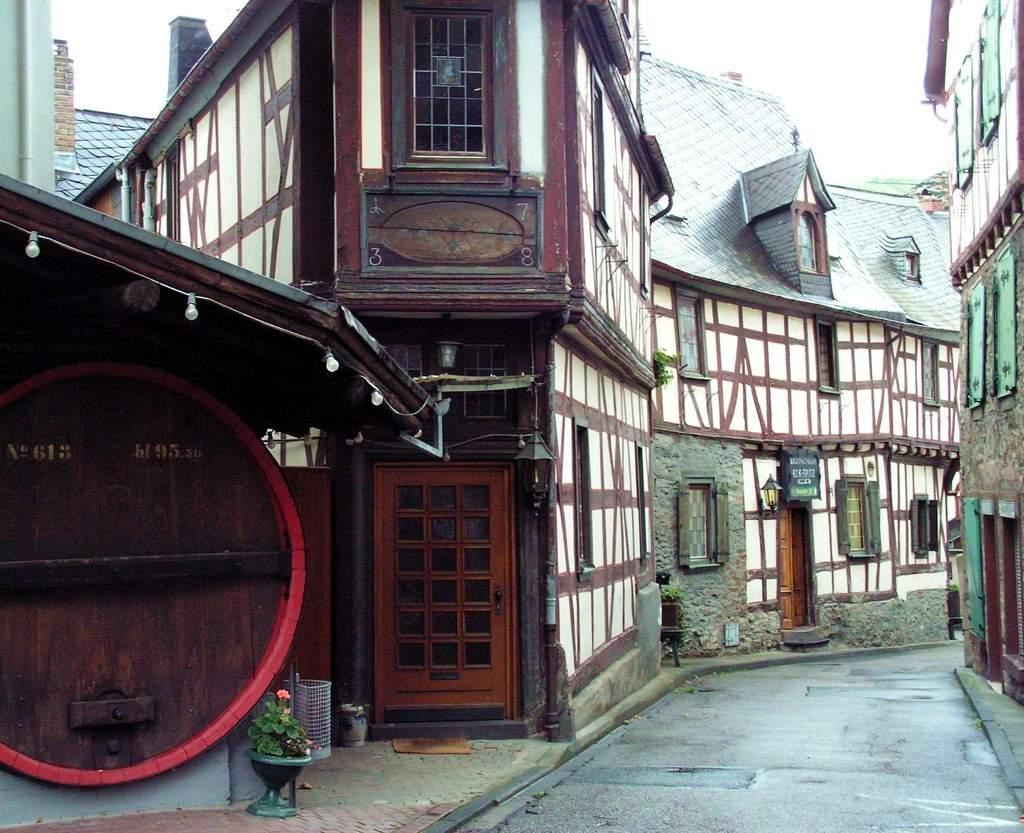What structures are located in the middle of the image? There are buildings in the middle of the image. What else can be seen in the middle of the image besides the buildings? There are lights visible in the middle of the image. What is visible at the top of the image? The sky is visible at the top of the image. What type of vegetation is at the bottom of the image? There is a plant at the bottom of the image. What type of skirt is hanging from the building in the image? There is no skirt present in the image; it features buildings, lights, the sky, and a plant. At what point does the image end? The image does not have a specific end point, as it is a digital representation of a scene. 